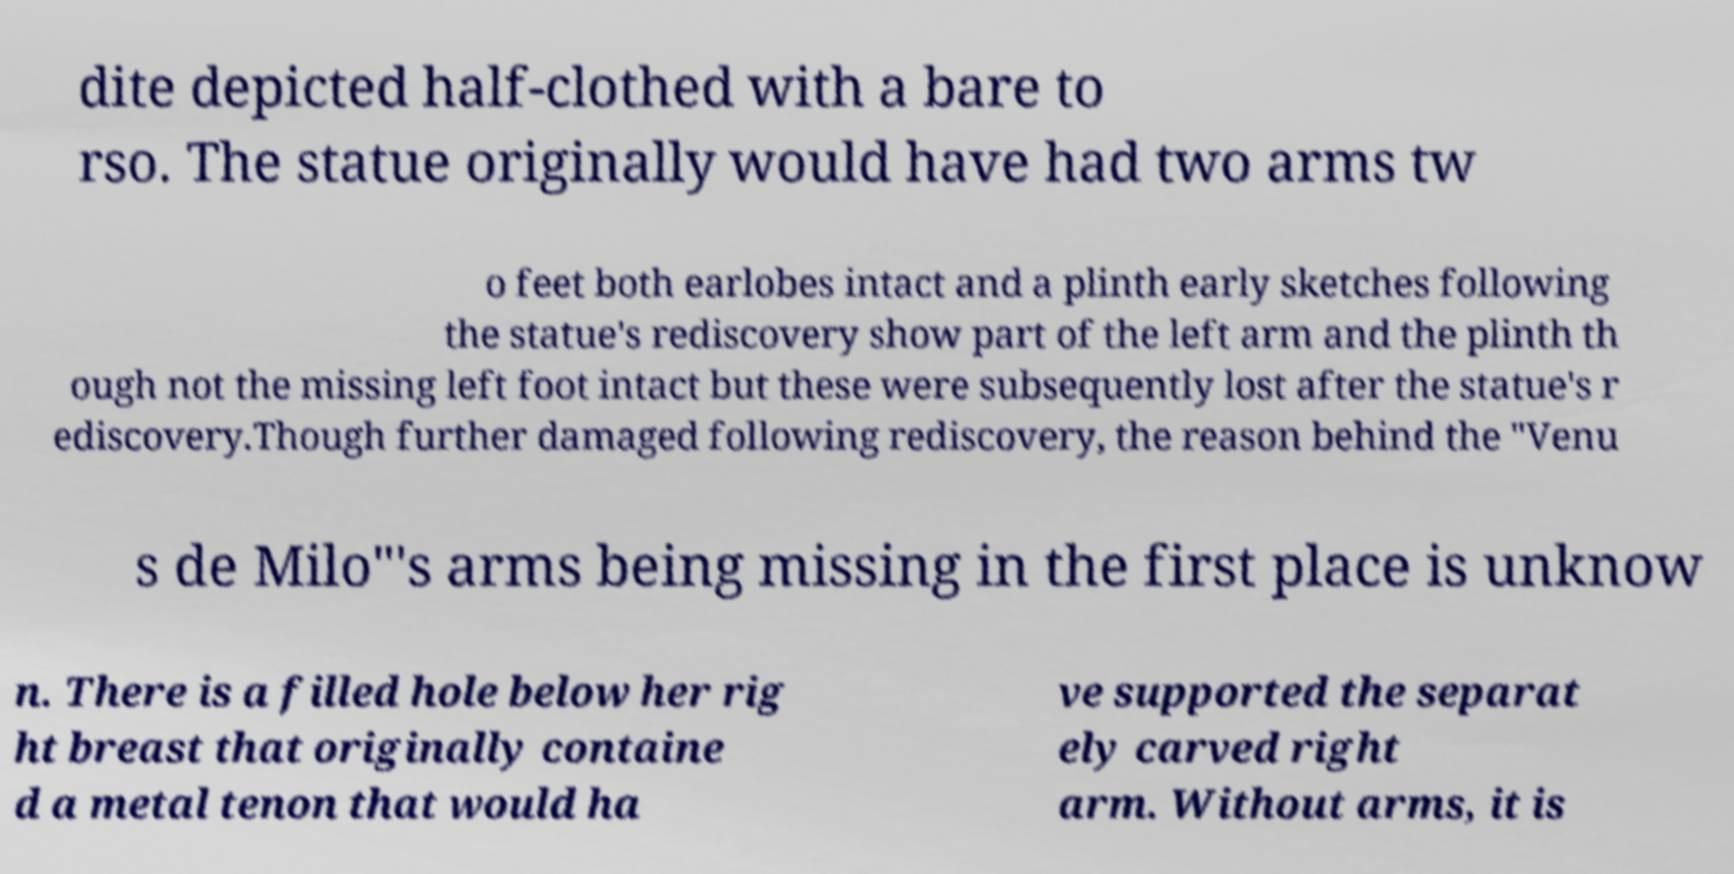Could you assist in decoding the text presented in this image and type it out clearly? dite depicted half-clothed with a bare to rso. The statue originally would have had two arms tw o feet both earlobes intact and a plinth early sketches following the statue's rediscovery show part of the left arm and the plinth th ough not the missing left foot intact but these were subsequently lost after the statue's r ediscovery.Though further damaged following rediscovery, the reason behind the "Venu s de Milo"'s arms being missing in the first place is unknow n. There is a filled hole below her rig ht breast that originally containe d a metal tenon that would ha ve supported the separat ely carved right arm. Without arms, it is 